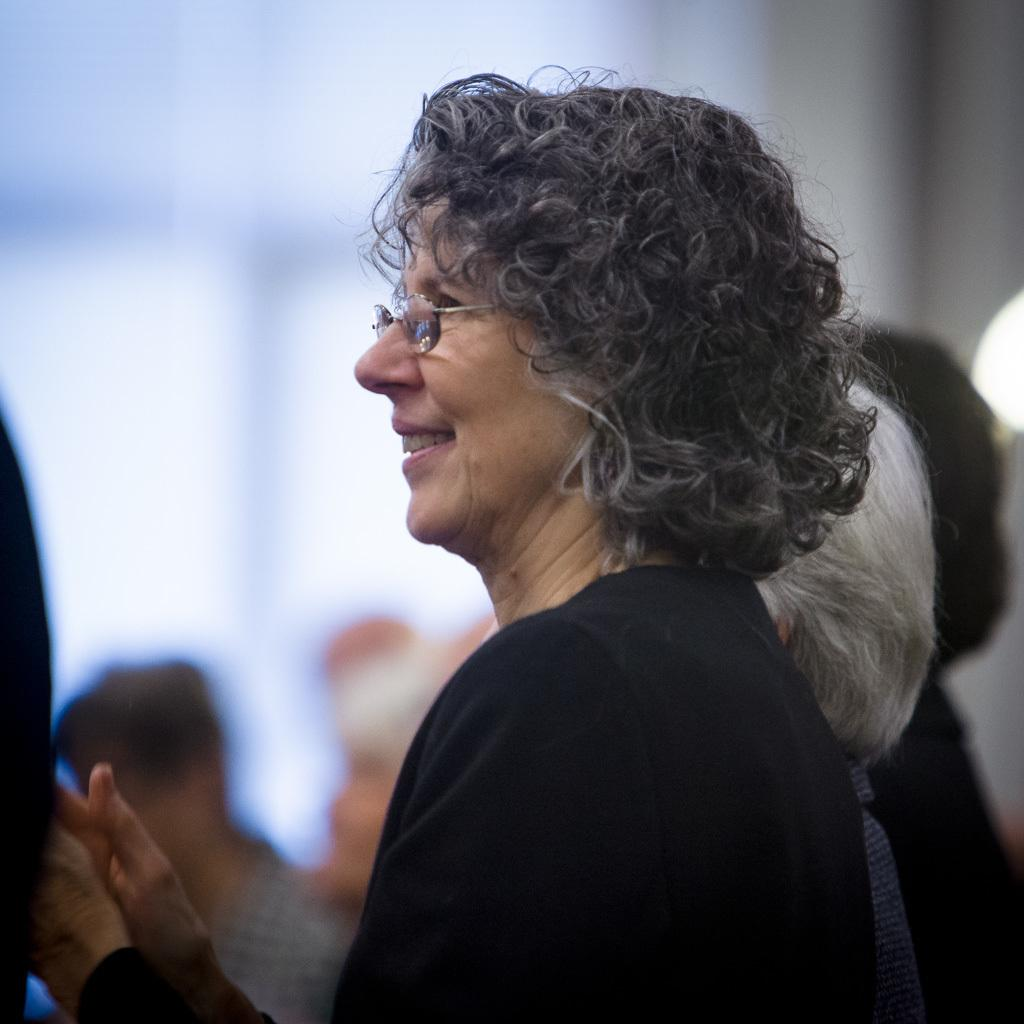How many people are in the image? There is a group of people in the image, but the exact number cannot be determined without more information. What can be seen in the background of the image? The background of the image is blurred, so it is difficult to make out specific details. What type of game is being played by the people in the image? There is no game visible in the image, as it only shows a group of people and a blurred background. Can you tell me what kind of pet is sitting next to the people in the image? There is no pet present in the image; it only features a group of people and a blurred background. 